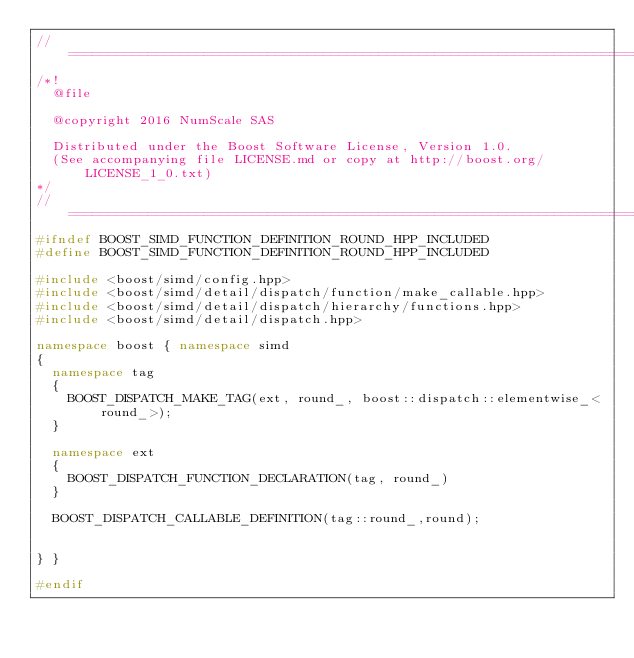<code> <loc_0><loc_0><loc_500><loc_500><_C++_>//==================================================================================================
/*!
  @file

  @copyright 2016 NumScale SAS

  Distributed under the Boost Software License, Version 1.0.
  (See accompanying file LICENSE.md or copy at http://boost.org/LICENSE_1_0.txt)
*/
//==================================================================================================
#ifndef BOOST_SIMD_FUNCTION_DEFINITION_ROUND_HPP_INCLUDED
#define BOOST_SIMD_FUNCTION_DEFINITION_ROUND_HPP_INCLUDED

#include <boost/simd/config.hpp>
#include <boost/simd/detail/dispatch/function/make_callable.hpp>
#include <boost/simd/detail/dispatch/hierarchy/functions.hpp>
#include <boost/simd/detail/dispatch.hpp>

namespace boost { namespace simd
{
  namespace tag
  {
    BOOST_DISPATCH_MAKE_TAG(ext, round_, boost::dispatch::elementwise_<round_>);
  }

  namespace ext
  {
    BOOST_DISPATCH_FUNCTION_DECLARATION(tag, round_)
  }

  BOOST_DISPATCH_CALLABLE_DEFINITION(tag::round_,round);


} }

#endif
</code> 